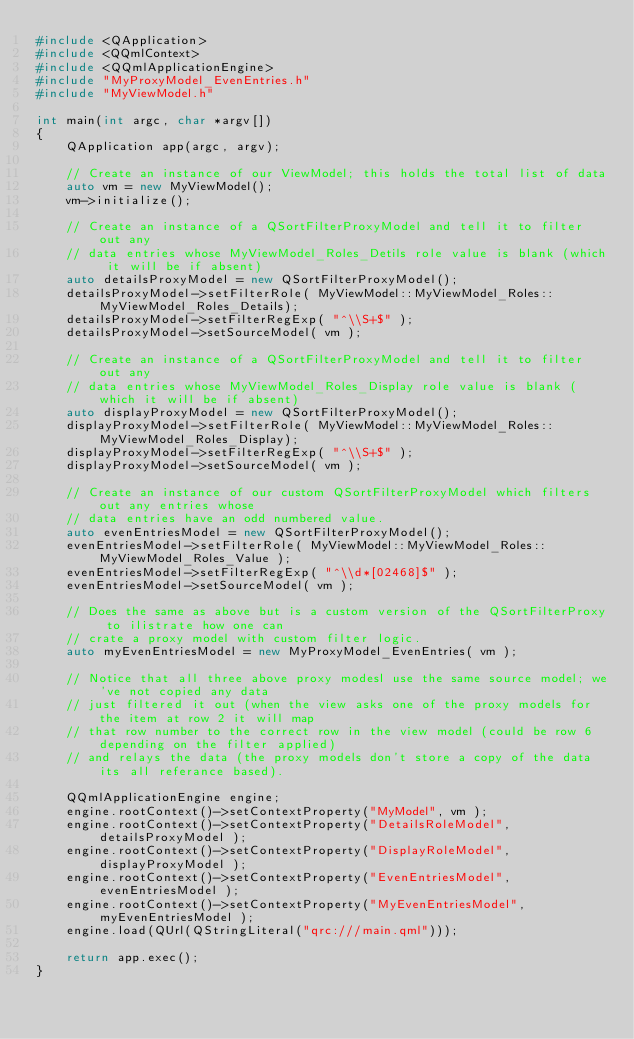Convert code to text. <code><loc_0><loc_0><loc_500><loc_500><_C++_>#include <QApplication>
#include <QQmlContext>
#include <QQmlApplicationEngine>
#include "MyProxyModel_EvenEntries.h"
#include "MyViewModel.h"

int main(int argc, char *argv[])
{
    QApplication app(argc, argv);

    // Create an instance of our ViewModel; this holds the total list of data
    auto vm = new MyViewModel();
    vm->initialize();

    // Create an instance of a QSortFilterProxyModel and tell it to filter out any
    // data entries whose MyViewModel_Roles_Detils role value is blank (which it will be if absent)
    auto detailsProxyModel = new QSortFilterProxyModel();
    detailsProxyModel->setFilterRole( MyViewModel::MyViewModel_Roles::MyViewModel_Roles_Details);
    detailsProxyModel->setFilterRegExp( "^\\S+$" );
    detailsProxyModel->setSourceModel( vm );

    // Create an instance of a QSortFilterProxyModel and tell it to filter out any
    // data entries whose MyViewModel_Roles_Display role value is blank (which it will be if absent)
    auto displayProxyModel = new QSortFilterProxyModel();
    displayProxyModel->setFilterRole( MyViewModel::MyViewModel_Roles::MyViewModel_Roles_Display);
    displayProxyModel->setFilterRegExp( "^\\S+$" );
    displayProxyModel->setSourceModel( vm );

    // Create an instance of our custom QSortFilterProxyModel which filters out any entries whose
    // data entries have an odd numbered value.
    auto evenEntriesModel = new QSortFilterProxyModel();
    evenEntriesModel->setFilterRole( MyViewModel::MyViewModel_Roles::MyViewModel_Roles_Value );
    evenEntriesModel->setFilterRegExp( "^\\d*[02468]$" );
    evenEntriesModel->setSourceModel( vm );

    // Does the same as above but is a custom version of the QSortFilterProxy to ilistrate how one can
    // crate a proxy model with custom filter logic.
    auto myEvenEntriesModel = new MyProxyModel_EvenEntries( vm );

    // Notice that all three above proxy modesl use the same source model; we've not copied any data
    // just filtered it out (when the view asks one of the proxy models for the item at row 2 it will map
    // that row number to the correct row in the view model (could be row 6 depending on the filter applied)
    // and relays the data (the proxy models don't store a copy of the data its all referance based).

    QQmlApplicationEngine engine;
    engine.rootContext()->setContextProperty("MyModel", vm );
    engine.rootContext()->setContextProperty("DetailsRoleModel", detailsProxyModel );
    engine.rootContext()->setContextProperty("DisplayRoleModel", displayProxyModel );
    engine.rootContext()->setContextProperty("EvenEntriesModel", evenEntriesModel );
    engine.rootContext()->setContextProperty("MyEvenEntriesModel", myEvenEntriesModel );
    engine.load(QUrl(QStringLiteral("qrc:///main.qml")));

    return app.exec();
}
</code> 